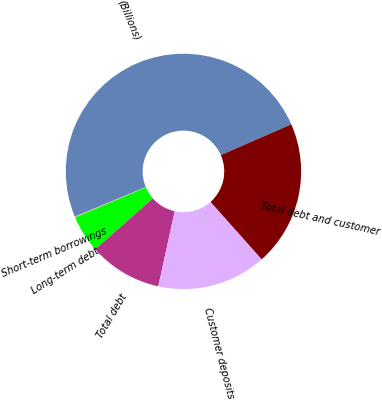Convert chart. <chart><loc_0><loc_0><loc_500><loc_500><pie_chart><fcel>(Billions)<fcel>Short-term borrowings<fcel>Long-term debt<fcel>Total debt<fcel>Customer deposits<fcel>Total debt and customer<nl><fcel>49.72%<fcel>0.14%<fcel>5.1%<fcel>10.06%<fcel>15.01%<fcel>19.97%<nl></chart> 